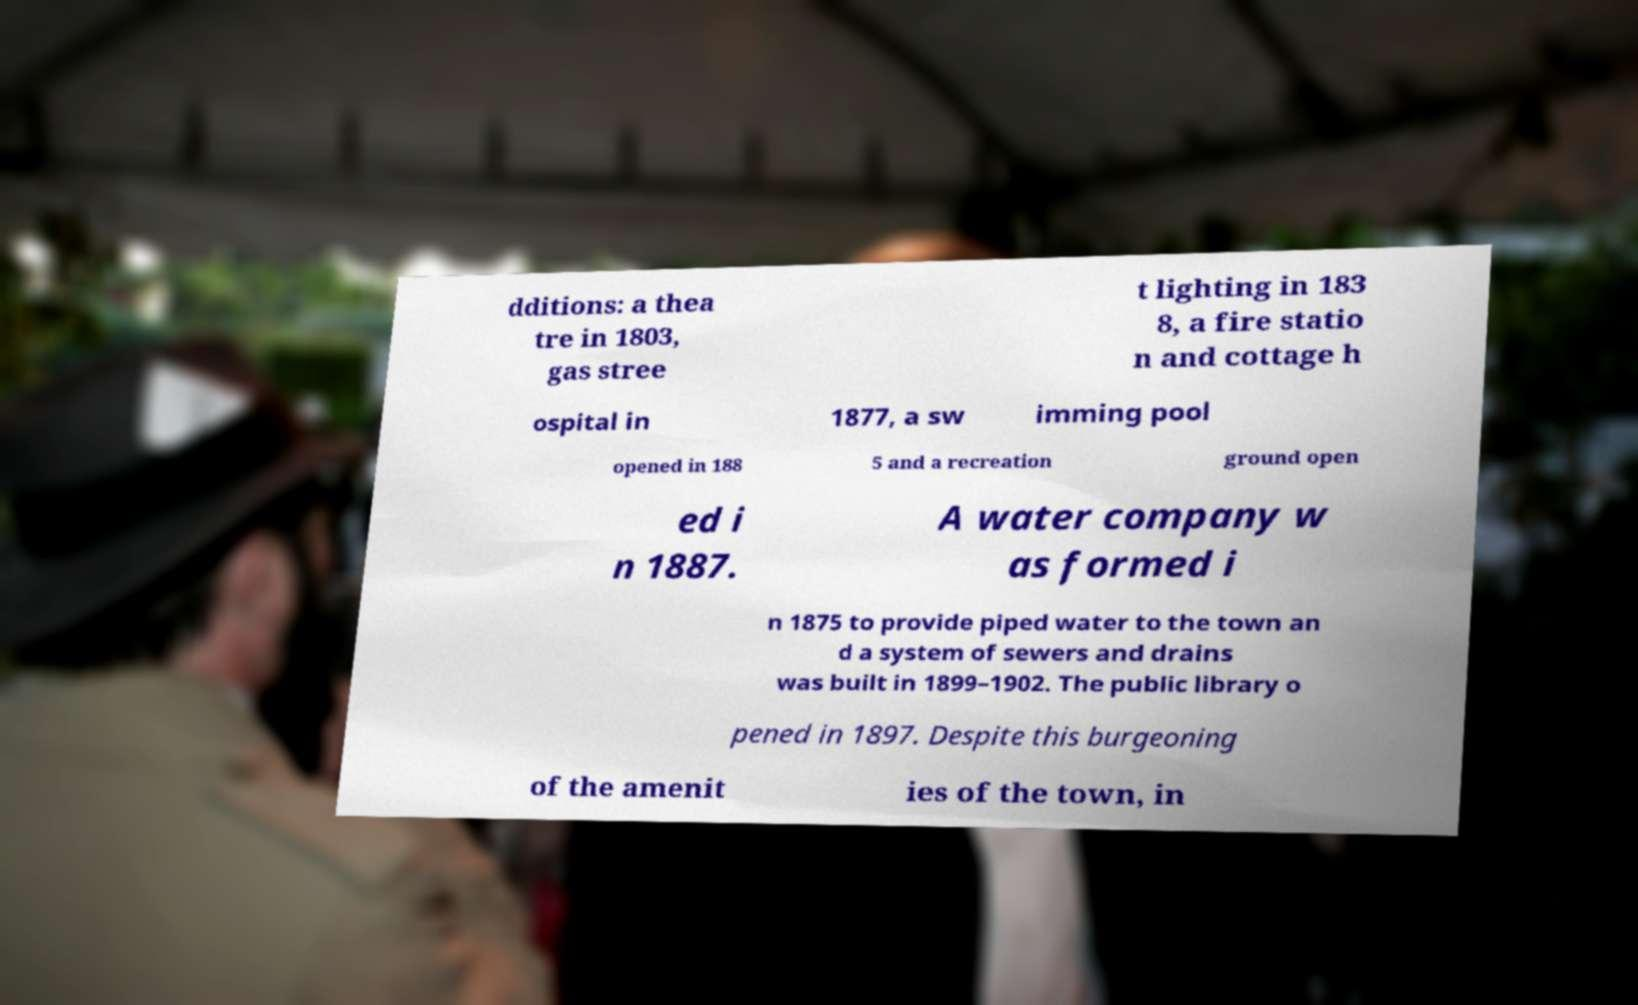Could you assist in decoding the text presented in this image and type it out clearly? dditions: a thea tre in 1803, gas stree t lighting in 183 8, a fire statio n and cottage h ospital in 1877, a sw imming pool opened in 188 5 and a recreation ground open ed i n 1887. A water company w as formed i n 1875 to provide piped water to the town an d a system of sewers and drains was built in 1899–1902. The public library o pened in 1897. Despite this burgeoning of the amenit ies of the town, in 